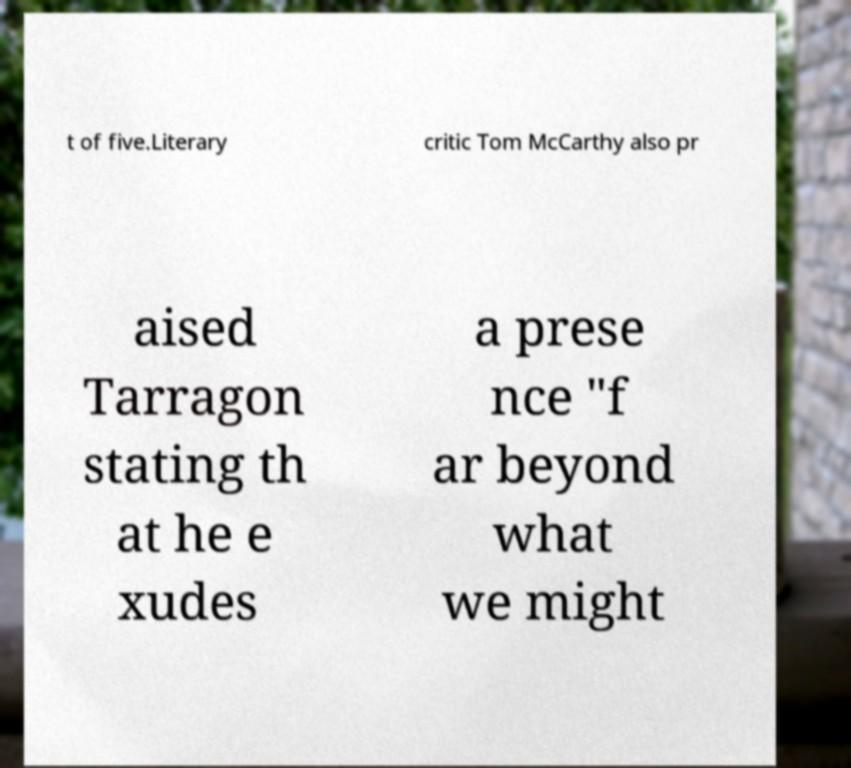There's text embedded in this image that I need extracted. Can you transcribe it verbatim? t of five.Literary critic Tom McCarthy also pr aised Tarragon stating th at he e xudes a prese nce "f ar beyond what we might 